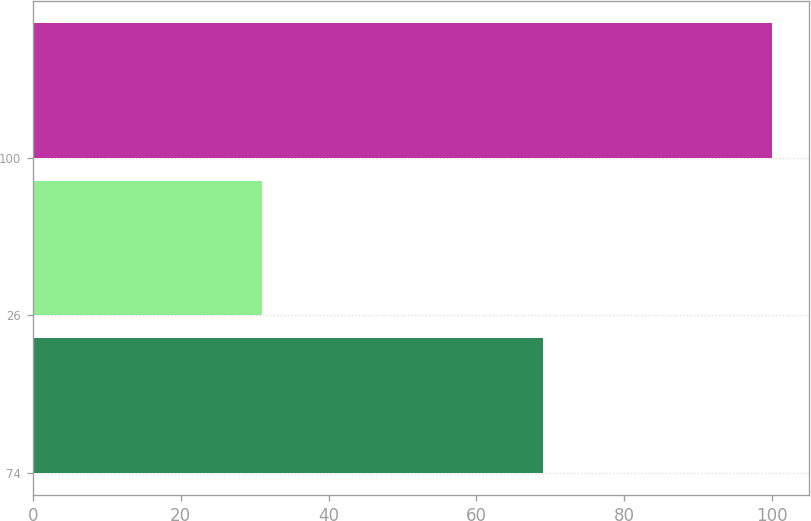Convert chart to OTSL. <chart><loc_0><loc_0><loc_500><loc_500><bar_chart><fcel>74<fcel>26<fcel>100<nl><fcel>69<fcel>31<fcel>100<nl></chart> 